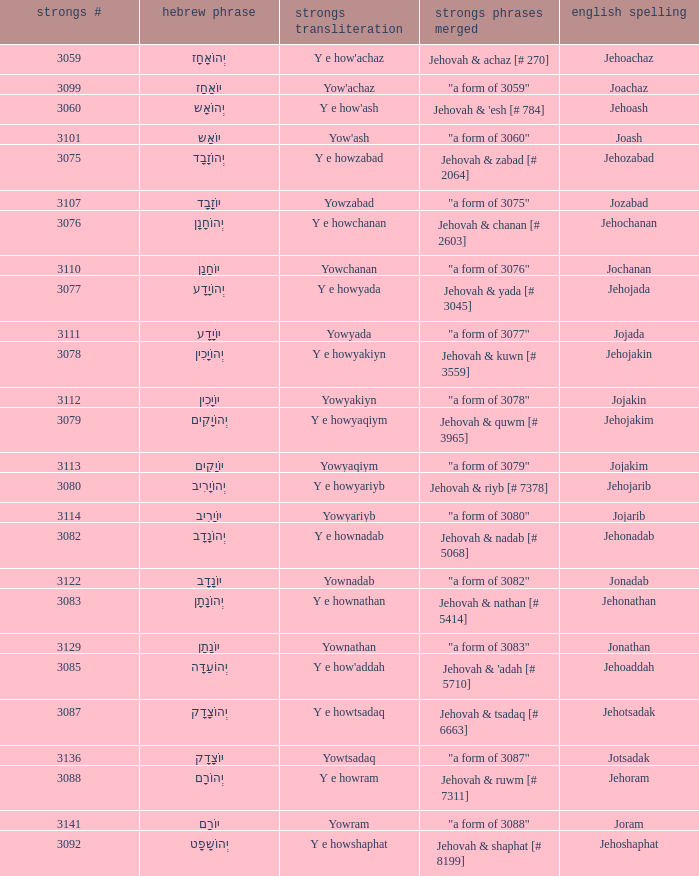What is the strongs words compounded when the english spelling is jonadab? "a form of 3082". 